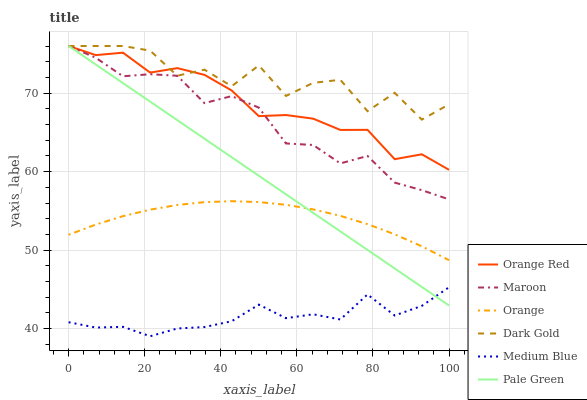Does Medium Blue have the minimum area under the curve?
Answer yes or no. Yes. Does Dark Gold have the maximum area under the curve?
Answer yes or no. Yes. Does Maroon have the minimum area under the curve?
Answer yes or no. No. Does Maroon have the maximum area under the curve?
Answer yes or no. No. Is Pale Green the smoothest?
Answer yes or no. Yes. Is Dark Gold the roughest?
Answer yes or no. Yes. Is Medium Blue the smoothest?
Answer yes or no. No. Is Medium Blue the roughest?
Answer yes or no. No. Does Medium Blue have the lowest value?
Answer yes or no. Yes. Does Maroon have the lowest value?
Answer yes or no. No. Does Orange Red have the highest value?
Answer yes or no. Yes. Does Medium Blue have the highest value?
Answer yes or no. No. Is Medium Blue less than Orange Red?
Answer yes or no. Yes. Is Dark Gold greater than Orange?
Answer yes or no. Yes. Does Maroon intersect Dark Gold?
Answer yes or no. Yes. Is Maroon less than Dark Gold?
Answer yes or no. No. Is Maroon greater than Dark Gold?
Answer yes or no. No. Does Medium Blue intersect Orange Red?
Answer yes or no. No. 